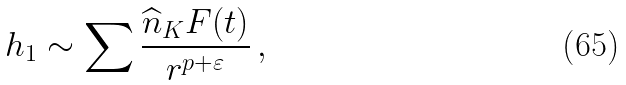Convert formula to latex. <formula><loc_0><loc_0><loc_500><loc_500>h _ { 1 } \sim \sum \frac { \widehat { n } _ { K } F ( t ) } { r ^ { p + \varepsilon } } \, ,</formula> 